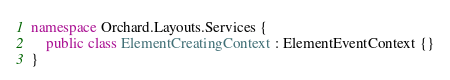Convert code to text. <code><loc_0><loc_0><loc_500><loc_500><_C#_>namespace Orchard.Layouts.Services {
    public class ElementCreatingContext : ElementEventContext {}
}</code> 